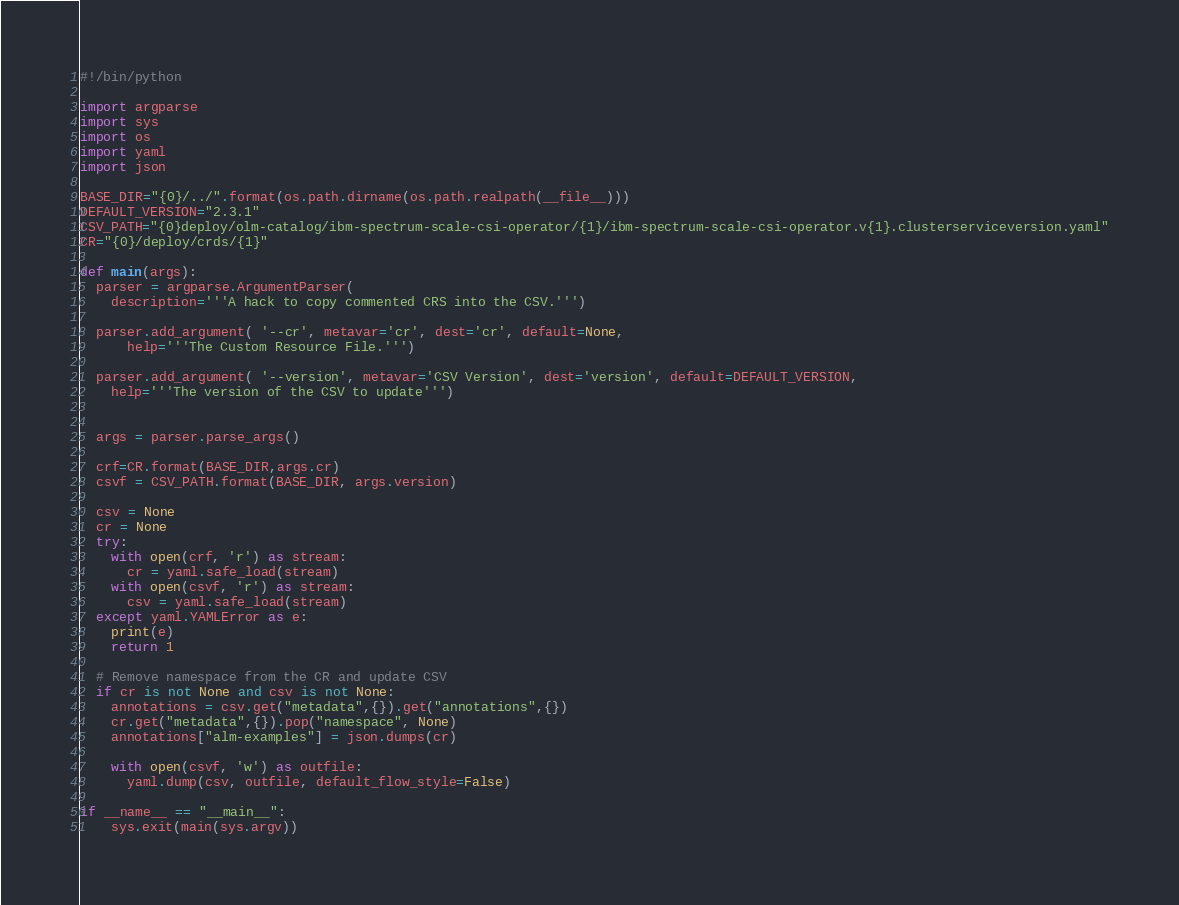<code> <loc_0><loc_0><loc_500><loc_500><_Python_>#!/bin/python

import argparse
import sys
import os
import yaml
import json

BASE_DIR="{0}/../".format(os.path.dirname(os.path.realpath(__file__)))
DEFAULT_VERSION="2.3.1"
CSV_PATH="{0}deploy/olm-catalog/ibm-spectrum-scale-csi-operator/{1}/ibm-spectrum-scale-csi-operator.v{1}.clusterserviceversion.yaml"
CR="{0}/deploy/crds/{1}"

def main(args):
  parser = argparse.ArgumentParser(
    description='''A hack to copy commented CRS into the CSV.''')
  
  parser.add_argument( '--cr', metavar='cr', dest='cr', default=None,
      help='''The Custom Resource File.''')

  parser.add_argument( '--version', metavar='CSV Version', dest='version', default=DEFAULT_VERSION,
    help='''The version of the CSV to update''')


  args = parser.parse_args()

  crf=CR.format(BASE_DIR,args.cr)
  csvf = CSV_PATH.format(BASE_DIR, args.version)

  csv = None
  cr = None
  try:
    with open(crf, 'r') as stream:
      cr = yaml.safe_load(stream)
    with open(csvf, 'r') as stream:
      csv = yaml.safe_load(stream)
  except yaml.YAMLError as e:
    print(e)
    return 1

  # Remove namespace from the CR and update CSV
  if cr is not None and csv is not None:
    annotations = csv.get("metadata",{}).get("annotations",{})
    cr.get("metadata",{}).pop("namespace", None)
    annotations["alm-examples"] = json.dumps(cr)

    with open(csvf, 'w') as outfile:
      yaml.dump(csv, outfile, default_flow_style=False)
      
if __name__ == "__main__":
    sys.exit(main(sys.argv))

</code> 